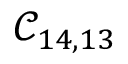Convert formula to latex. <formula><loc_0><loc_0><loc_500><loc_500>\mathcal { C } _ { 1 4 , 1 3 }</formula> 